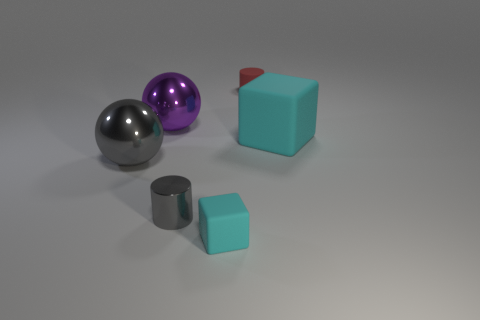What is the size of the other cyan object that is the same shape as the small cyan rubber object?
Keep it short and to the point. Large. There is a cyan matte object in front of the cyan matte object behind the sphere that is in front of the large matte thing; what shape is it?
Offer a terse response. Cube. There is a tiny thing that is in front of the small metal cylinder; does it have the same color as the small rubber thing behind the purple metal object?
Offer a terse response. No. Is there any other thing that has the same size as the gray metal sphere?
Offer a very short reply. Yes. Are there any cyan things in front of the gray sphere?
Offer a terse response. Yes. What number of big cyan objects have the same shape as the red object?
Offer a very short reply. 0. The tiny cylinder that is left of the cube to the left of the cube behind the tiny cyan block is what color?
Keep it short and to the point. Gray. Is the material of the small cylinder left of the small block the same as the large ball behind the big gray metal thing?
Offer a very short reply. Yes. What number of things are cylinders behind the small metallic thing or tiny blue rubber things?
Make the answer very short. 1. How many things are large cyan matte objects or cyan matte things on the left side of the large cyan thing?
Offer a very short reply. 2. 